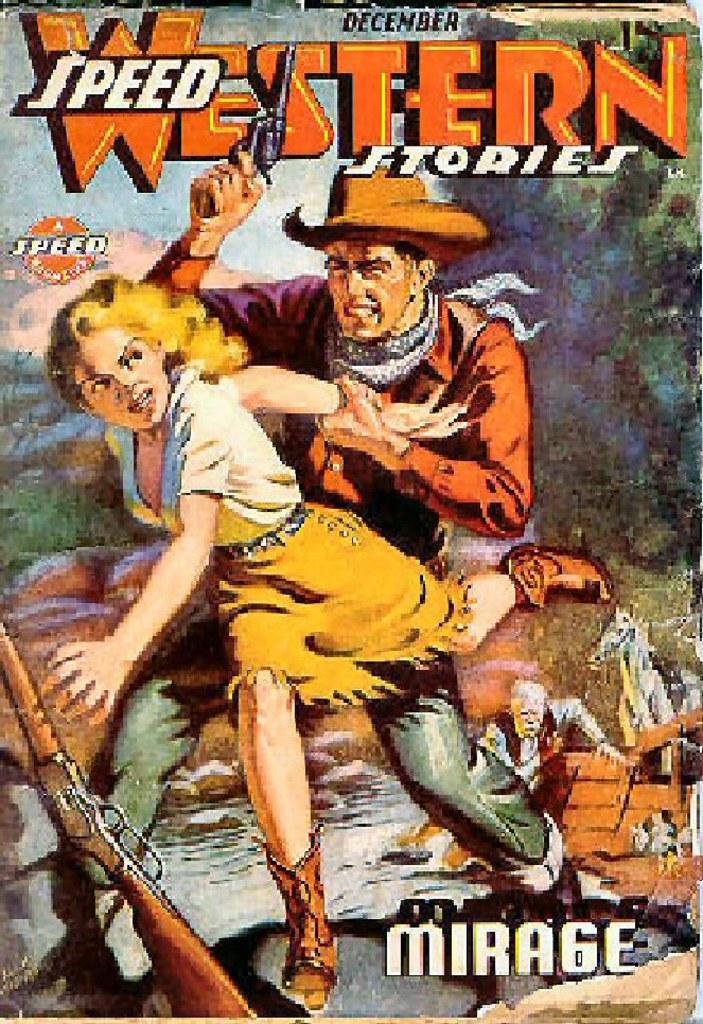What kind of stories is the book about?
Your answer should be very brief. Western. What month is this edition from?
Your response must be concise. December. 